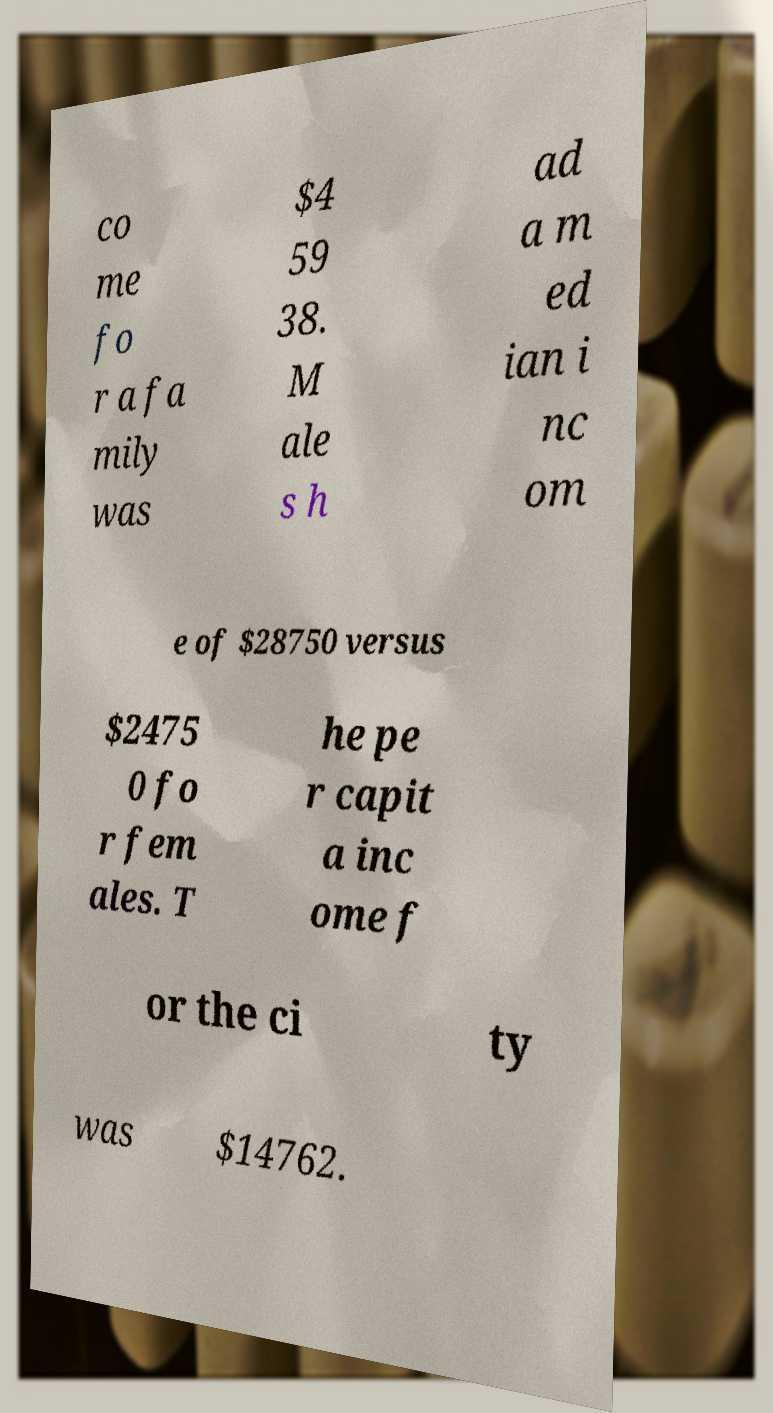What messages or text are displayed in this image? I need them in a readable, typed format. co me fo r a fa mily was $4 59 38. M ale s h ad a m ed ian i nc om e of $28750 versus $2475 0 fo r fem ales. T he pe r capit a inc ome f or the ci ty was $14762. 